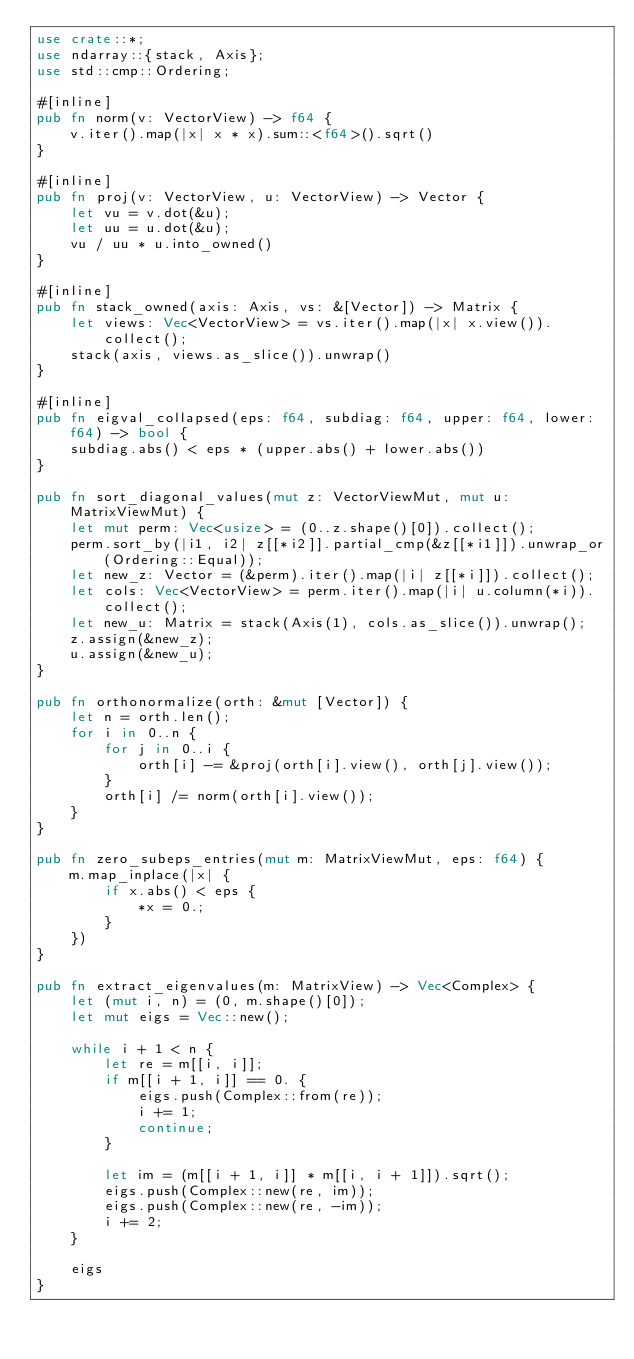Convert code to text. <code><loc_0><loc_0><loc_500><loc_500><_Rust_>use crate::*;
use ndarray::{stack, Axis};
use std::cmp::Ordering;

#[inline]
pub fn norm(v: VectorView) -> f64 {
    v.iter().map(|x| x * x).sum::<f64>().sqrt()
}

#[inline]
pub fn proj(v: VectorView, u: VectorView) -> Vector {
    let vu = v.dot(&u);
    let uu = u.dot(&u);
    vu / uu * u.into_owned()
}

#[inline]
pub fn stack_owned(axis: Axis, vs: &[Vector]) -> Matrix {
    let views: Vec<VectorView> = vs.iter().map(|x| x.view()).collect();
    stack(axis, views.as_slice()).unwrap()
}

#[inline]
pub fn eigval_collapsed(eps: f64, subdiag: f64, upper: f64, lower: f64) -> bool {
    subdiag.abs() < eps * (upper.abs() + lower.abs())
}

pub fn sort_diagonal_values(mut z: VectorViewMut, mut u: MatrixViewMut) {
    let mut perm: Vec<usize> = (0..z.shape()[0]).collect();
    perm.sort_by(|i1, i2| z[[*i2]].partial_cmp(&z[[*i1]]).unwrap_or(Ordering::Equal));
    let new_z: Vector = (&perm).iter().map(|i| z[[*i]]).collect();
    let cols: Vec<VectorView> = perm.iter().map(|i| u.column(*i)).collect();
    let new_u: Matrix = stack(Axis(1), cols.as_slice()).unwrap();
    z.assign(&new_z);
    u.assign(&new_u);
}

pub fn orthonormalize(orth: &mut [Vector]) {
    let n = orth.len();
    for i in 0..n {
        for j in 0..i {
            orth[i] -= &proj(orth[i].view(), orth[j].view());
        }
        orth[i] /= norm(orth[i].view());
    }
}

pub fn zero_subeps_entries(mut m: MatrixViewMut, eps: f64) {
    m.map_inplace(|x| {
        if x.abs() < eps {
            *x = 0.;
        }
    })
}

pub fn extract_eigenvalues(m: MatrixView) -> Vec<Complex> {
    let (mut i, n) = (0, m.shape()[0]);
    let mut eigs = Vec::new();

    while i + 1 < n {
        let re = m[[i, i]];
        if m[[i + 1, i]] == 0. {
            eigs.push(Complex::from(re));
            i += 1;
            continue;
        }

        let im = (m[[i + 1, i]] * m[[i, i + 1]]).sqrt();
        eigs.push(Complex::new(re, im));
        eigs.push(Complex::new(re, -im));
        i += 2;
    }

    eigs
}
</code> 